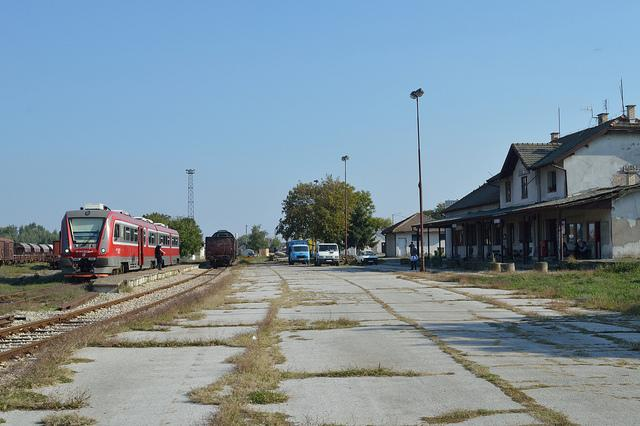What is the old rusted freight car in the background probably used to carry?

Choices:
A) oil
B) gas
C) water
D) coal coal 